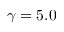Convert formula to latex. <formula><loc_0><loc_0><loc_500><loc_500>\gamma = 5 . 0</formula> 